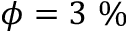Convert formula to latex. <formula><loc_0><loc_0><loc_500><loc_500>\phi = 3 \%</formula> 